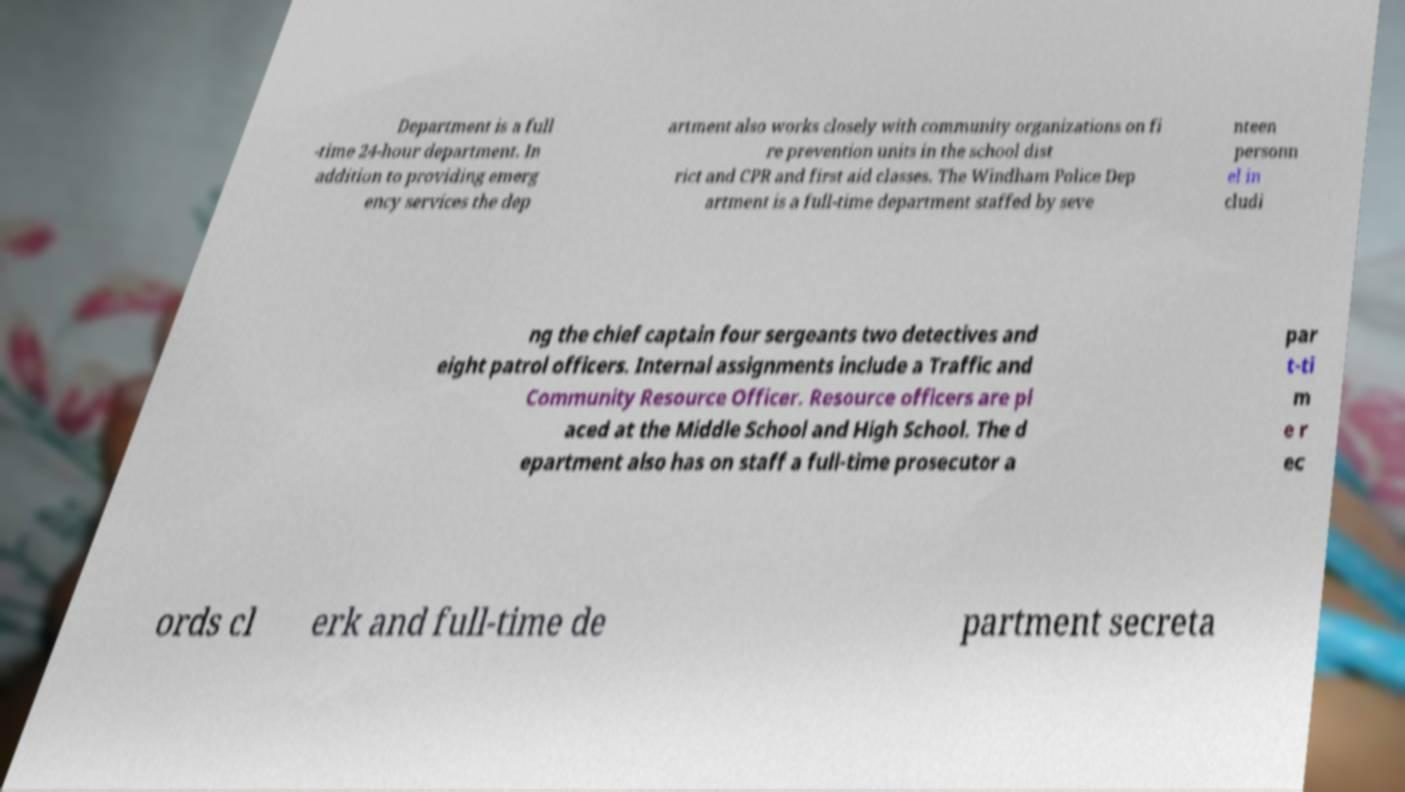For documentation purposes, I need the text within this image transcribed. Could you provide that? Department is a full -time 24-hour department. In addition to providing emerg ency services the dep artment also works closely with community organizations on fi re prevention units in the school dist rict and CPR and first aid classes. The Windham Police Dep artment is a full-time department staffed by seve nteen personn el in cludi ng the chief captain four sergeants two detectives and eight patrol officers. Internal assignments include a Traffic and Community Resource Officer. Resource officers are pl aced at the Middle School and High School. The d epartment also has on staff a full-time prosecutor a par t-ti m e r ec ords cl erk and full-time de partment secreta 